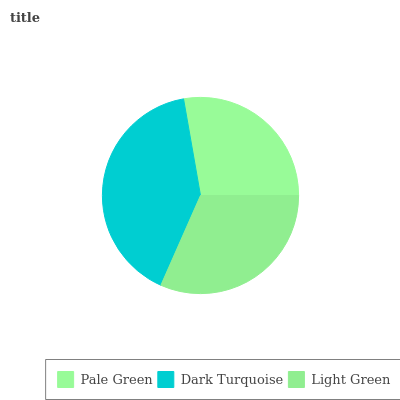Is Pale Green the minimum?
Answer yes or no. Yes. Is Dark Turquoise the maximum?
Answer yes or no. Yes. Is Light Green the minimum?
Answer yes or no. No. Is Light Green the maximum?
Answer yes or no. No. Is Dark Turquoise greater than Light Green?
Answer yes or no. Yes. Is Light Green less than Dark Turquoise?
Answer yes or no. Yes. Is Light Green greater than Dark Turquoise?
Answer yes or no. No. Is Dark Turquoise less than Light Green?
Answer yes or no. No. Is Light Green the high median?
Answer yes or no. Yes. Is Light Green the low median?
Answer yes or no. Yes. Is Dark Turquoise the high median?
Answer yes or no. No. Is Dark Turquoise the low median?
Answer yes or no. No. 